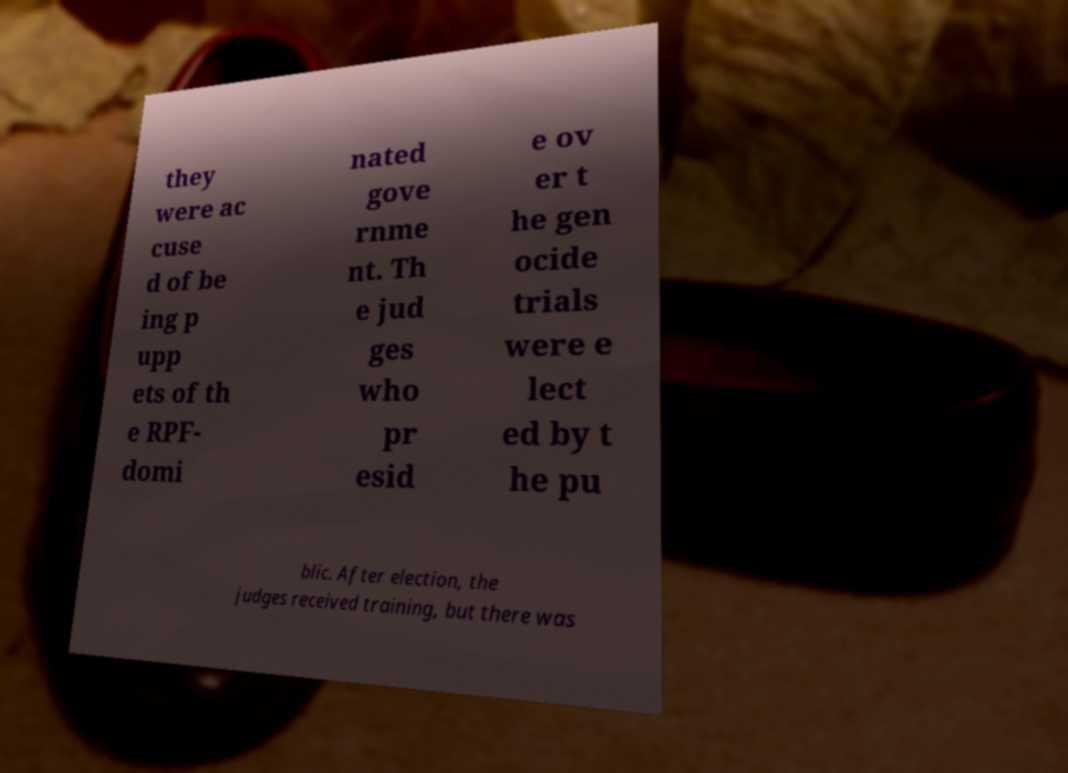Can you read and provide the text displayed in the image?This photo seems to have some interesting text. Can you extract and type it out for me? they were ac cuse d of be ing p upp ets of th e RPF- domi nated gove rnme nt. Th e jud ges who pr esid e ov er t he gen ocide trials were e lect ed by t he pu blic. After election, the judges received training, but there was 